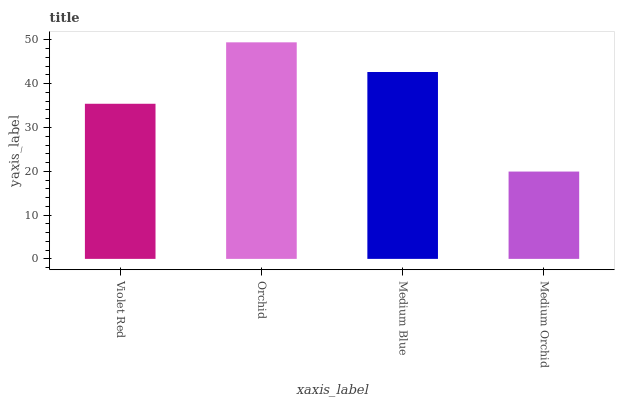Is Medium Orchid the minimum?
Answer yes or no. Yes. Is Orchid the maximum?
Answer yes or no. Yes. Is Medium Blue the minimum?
Answer yes or no. No. Is Medium Blue the maximum?
Answer yes or no. No. Is Orchid greater than Medium Blue?
Answer yes or no. Yes. Is Medium Blue less than Orchid?
Answer yes or no. Yes. Is Medium Blue greater than Orchid?
Answer yes or no. No. Is Orchid less than Medium Blue?
Answer yes or no. No. Is Medium Blue the high median?
Answer yes or no. Yes. Is Violet Red the low median?
Answer yes or no. Yes. Is Violet Red the high median?
Answer yes or no. No. Is Medium Orchid the low median?
Answer yes or no. No. 